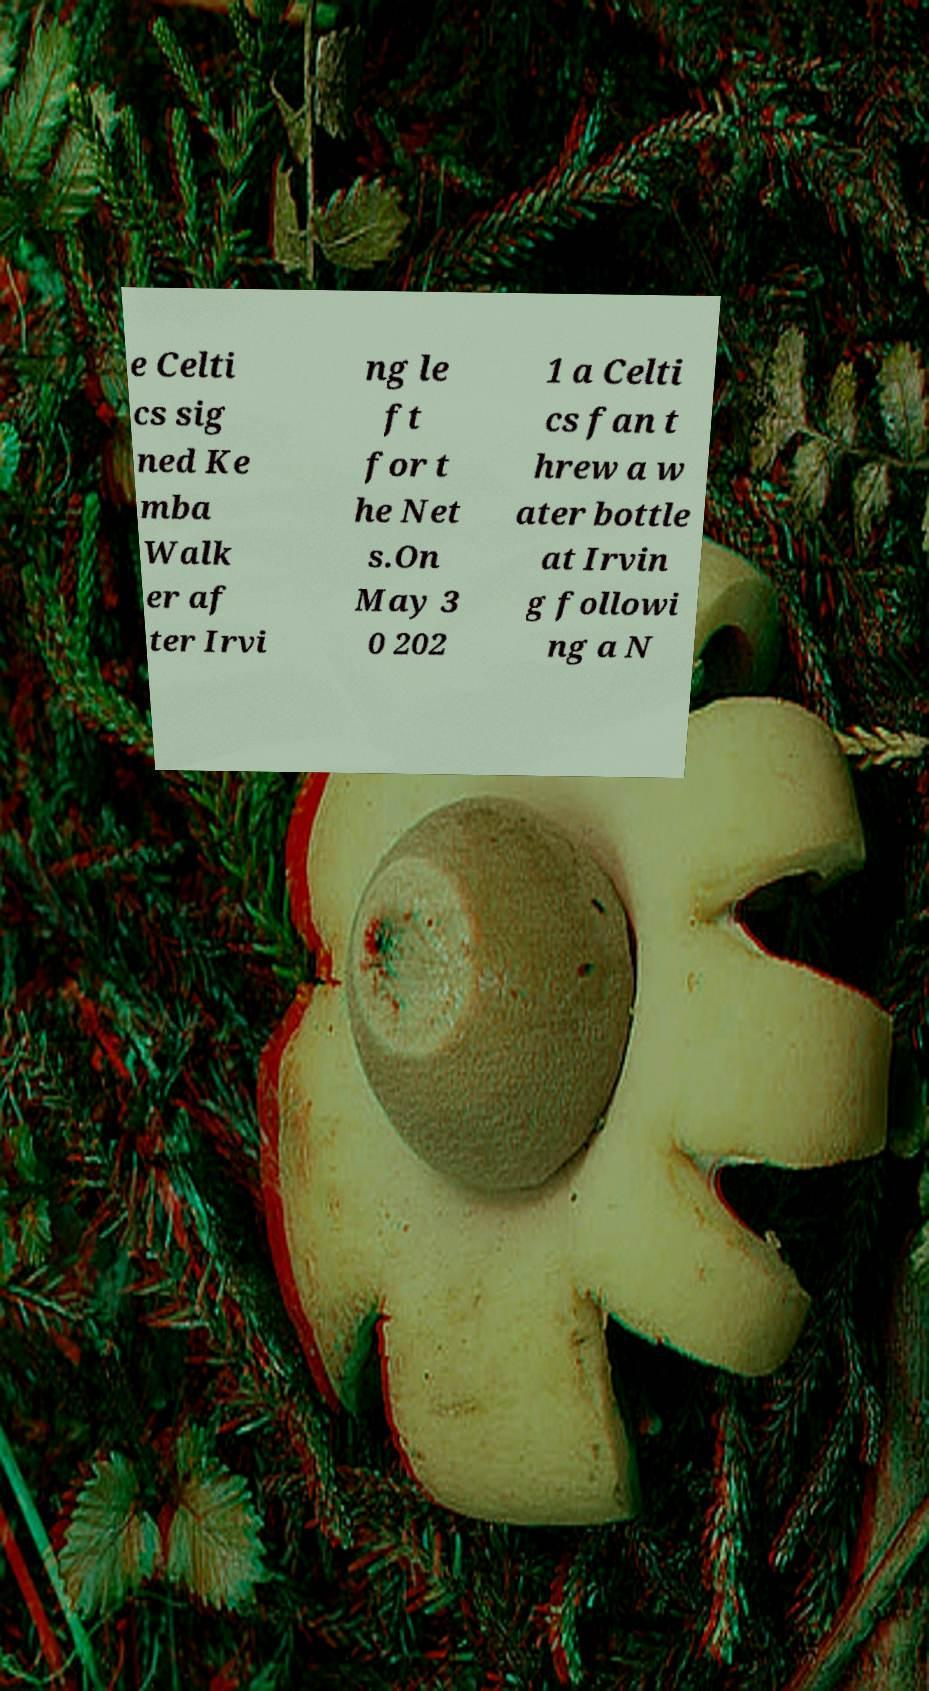Please read and relay the text visible in this image. What does it say? e Celti cs sig ned Ke mba Walk er af ter Irvi ng le ft for t he Net s.On May 3 0 202 1 a Celti cs fan t hrew a w ater bottle at Irvin g followi ng a N 